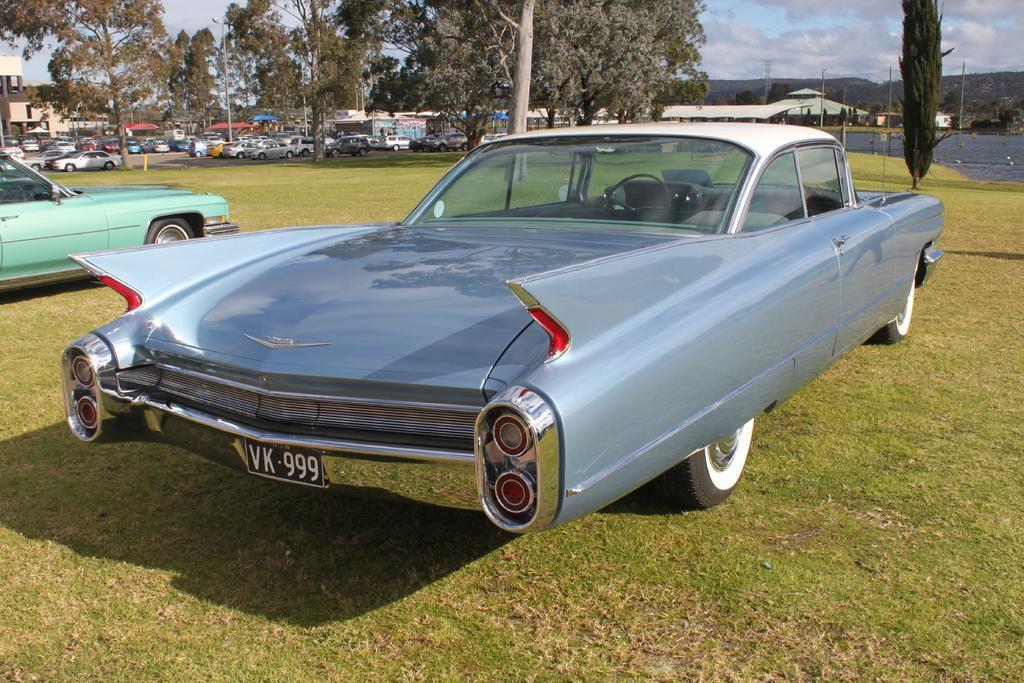How would you summarize this image in a sentence or two? In this image we can see group of vehicles parked on the ground. In the background, we can see a group of trees, buildings, poles, water and the sky. 